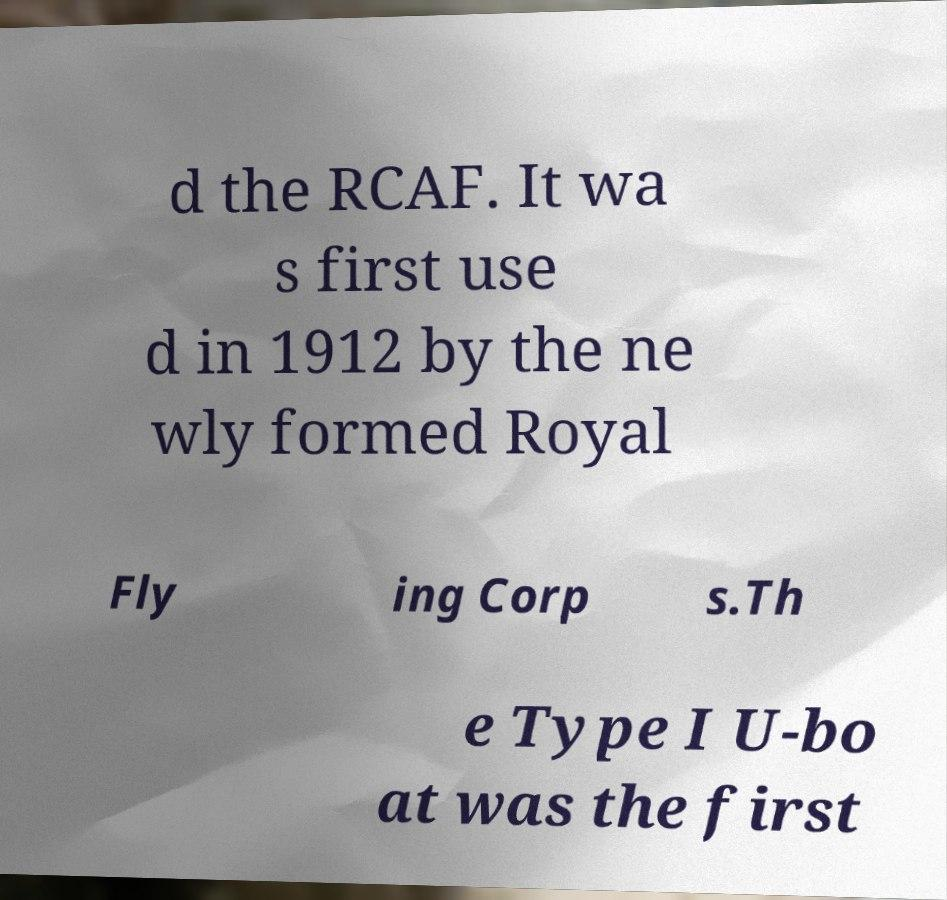What messages or text are displayed in this image? I need them in a readable, typed format. d the RCAF. It wa s first use d in 1912 by the ne wly formed Royal Fly ing Corp s.Th e Type I U-bo at was the first 